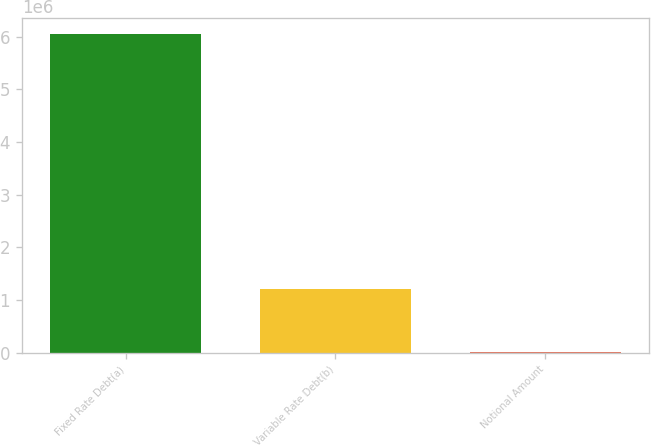Convert chart. <chart><loc_0><loc_0><loc_500><loc_500><bar_chart><fcel>Fixed Rate Debt(a)<fcel>Variable Rate Debt(b)<fcel>Notional Amount<nl><fcel>6.04726e+06<fcel>1.20695e+06<fcel>19226<nl></chart> 